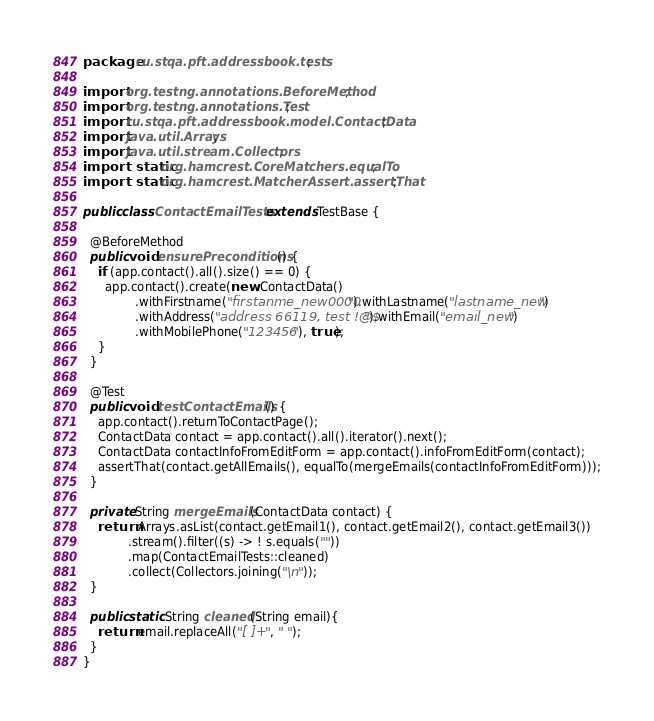<code> <loc_0><loc_0><loc_500><loc_500><_Java_>package ru.stqa.pft.addressbook.tests;

import org.testng.annotations.BeforeMethod;
import org.testng.annotations.Test;
import ru.stqa.pft.addressbook.model.ContactData;
import java.util.Arrays;
import java.util.stream.Collectors;
import static org.hamcrest.CoreMatchers.equalTo;
import static org.hamcrest.MatcherAssert.assertThat;

public class ContactEmailTests extends TestBase {

  @BeforeMethod
  public void ensurePreconditions() {
    if (app.contact().all().size() == 0) {
      app.contact().create(new ContactData()
              .withFirstname("firstanme_new0000").withLastname("lastname_new")
              .withAddress("address 66119, test !@$").withEmail("email_new")
              .withMobilePhone("123456"), true);
    }
  }

  @Test
  public void testContactEmails() {
    app.contact().returnToContactPage();
    ContactData contact = app.contact().all().iterator().next();
    ContactData contactInfoFromEditForm = app.contact().infoFromEditForm(contact);
    assertThat(contact.getAllEmails(), equalTo(mergeEmails(contactInfoFromEditForm)));
  }

  private String mergeEmails(ContactData contact) {
    return Arrays.asList(contact.getEmail1(), contact.getEmail2(), contact.getEmail3())
            .stream().filter((s) -> ! s.equals(""))
            .map(ContactEmailTests::cleaned)
            .collect(Collectors.joining("\n"));
  }

  public static String cleaned(String email){
    return email.replaceAll("[ ]+", " ");
  }
}
</code> 